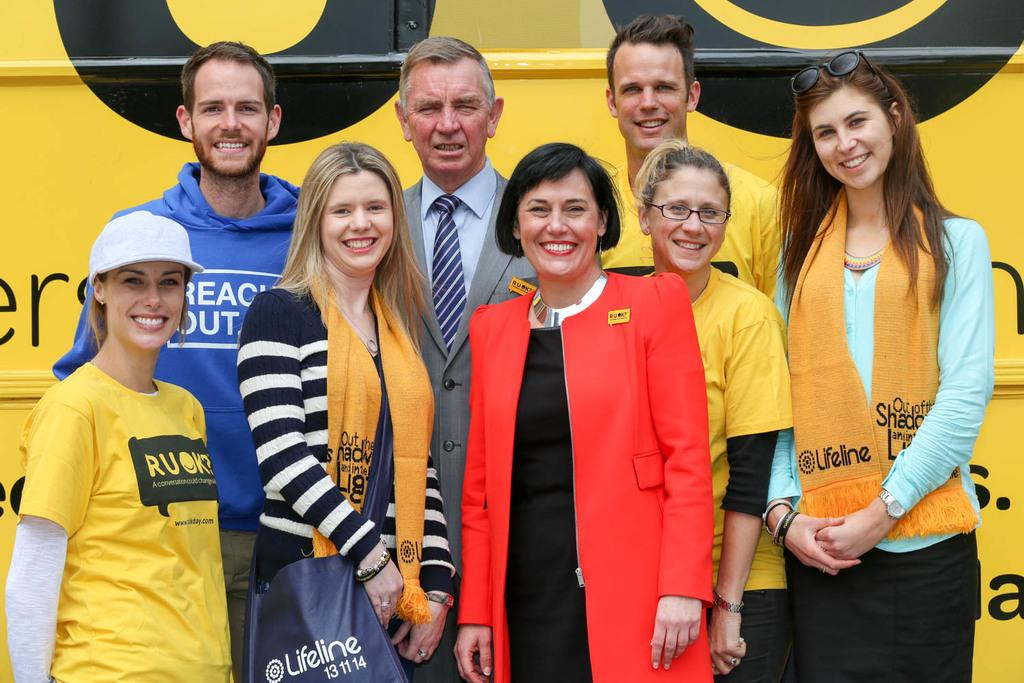<image>
Present a compact description of the photo's key features. A number of people pose for a photo sporting Lifeline merchandise. 